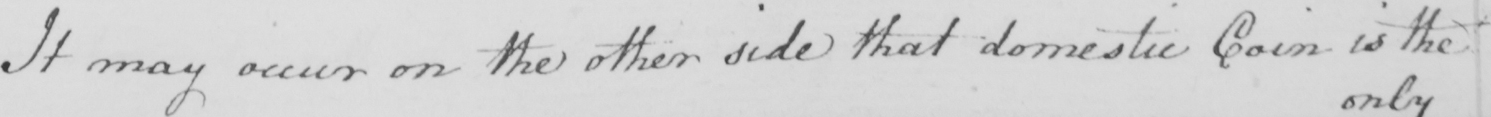Transcribe the text shown in this historical manuscript line. It may occur on the other side that domestic Coin is the 